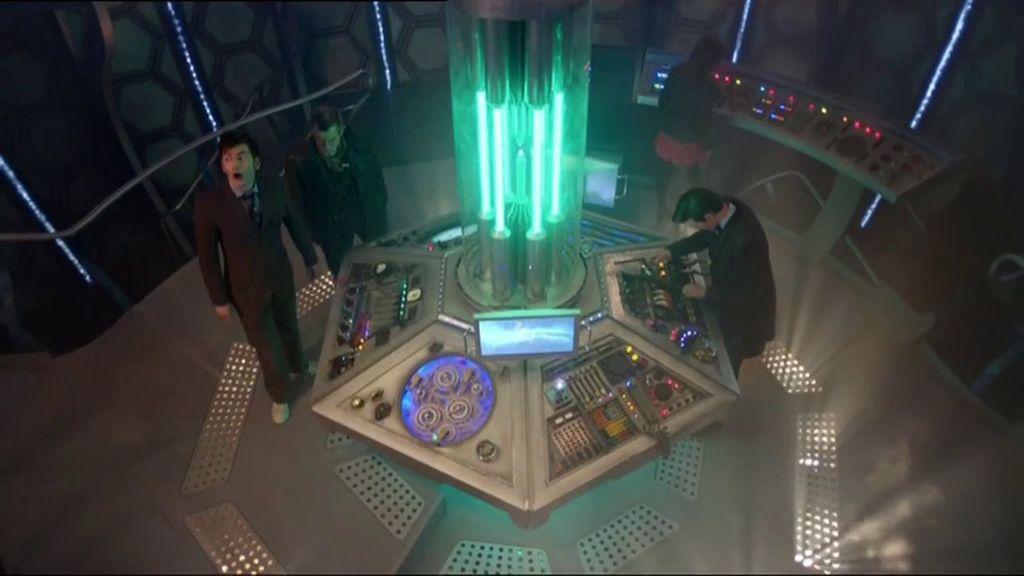How would you summarize this image in a sentence or two? In this image I can see the group of people. In-front of the people I can see the electronic machine, lights and the screen. To the right I can see one more electronic device. These people are standing inside the building. 